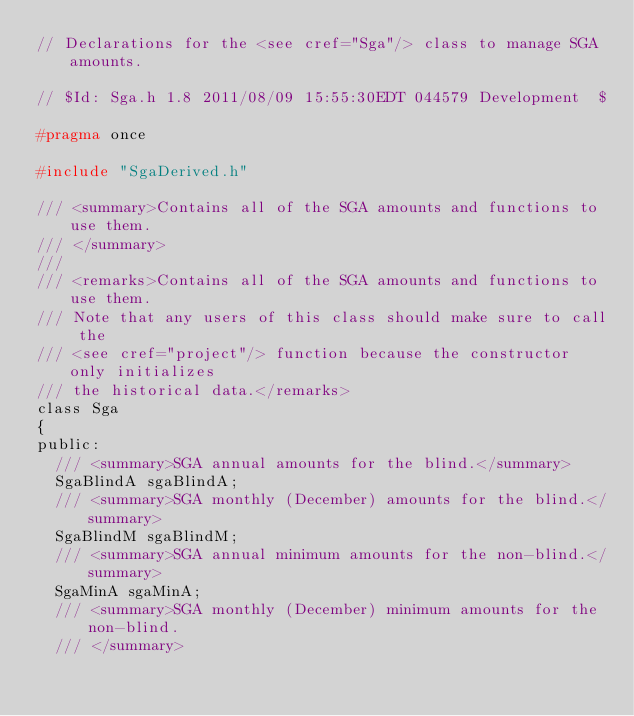<code> <loc_0><loc_0><loc_500><loc_500><_C_>// Declarations for the <see cref="Sga"/> class to manage SGA amounts.

// $Id: Sga.h 1.8 2011/08/09 15:55:30EDT 044579 Development  $

#pragma once

#include "SgaDerived.h"

/// <summary>Contains all of the SGA amounts and functions to use them.
/// </summary>
///
/// <remarks>Contains all of the SGA amounts and functions to use them.
/// Note that any users of this class should make sure to call the
/// <see cref="project"/> function because the constructor only initializes
/// the historical data.</remarks>
class Sga
{
public:
  /// <summary>SGA annual amounts for the blind.</summary>
  SgaBlindA sgaBlindA;
  /// <summary>SGA monthly (December) amounts for the blind.</summary>
  SgaBlindM sgaBlindM;
  /// <summary>SGA annual minimum amounts for the non-blind.</summary>
  SgaMinA sgaMinA;
  /// <summary>SGA monthly (December) minimum amounts for the non-blind.
  /// </summary></code> 